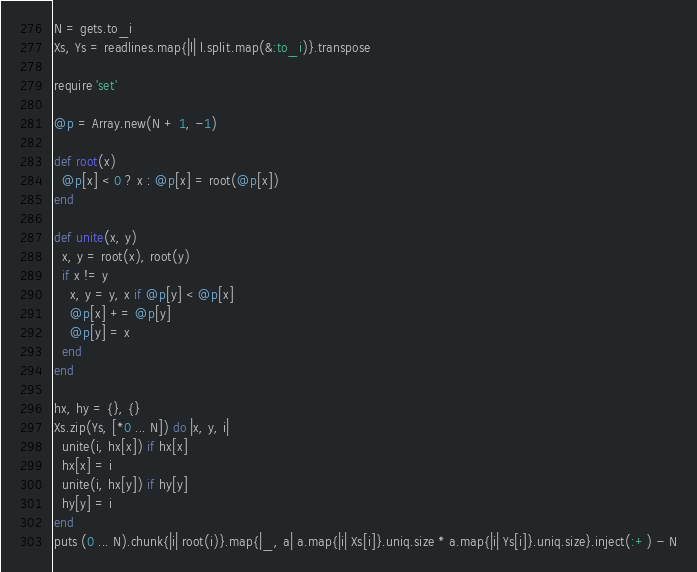Convert code to text. <code><loc_0><loc_0><loc_500><loc_500><_Ruby_>N = gets.to_i
Xs, Ys = readlines.map{|l| l.split.map(&:to_i)}.transpose

require 'set'

@p = Array.new(N + 1, -1)

def root(x)
  @p[x] < 0 ? x : @p[x] = root(@p[x])
end

def unite(x, y)
  x, y = root(x), root(y)
  if x != y
    x, y = y, x if @p[y] < @p[x]
    @p[x] += @p[y]
    @p[y] = x
  end
end

hx, hy = {}, {}
Xs.zip(Ys, [*0 ... N]) do |x, y, i|
  unite(i, hx[x]) if hx[x]
  hx[x] = i
  unite(i, hx[y]) if hy[y]
  hy[y] = i
end
puts (0 ... N).chunk{|i| root(i)}.map{|_, a| a.map{|i| Xs[i]}.uniq.size * a.map{|i| Ys[i]}.uniq.size}.inject(:+) - N</code> 